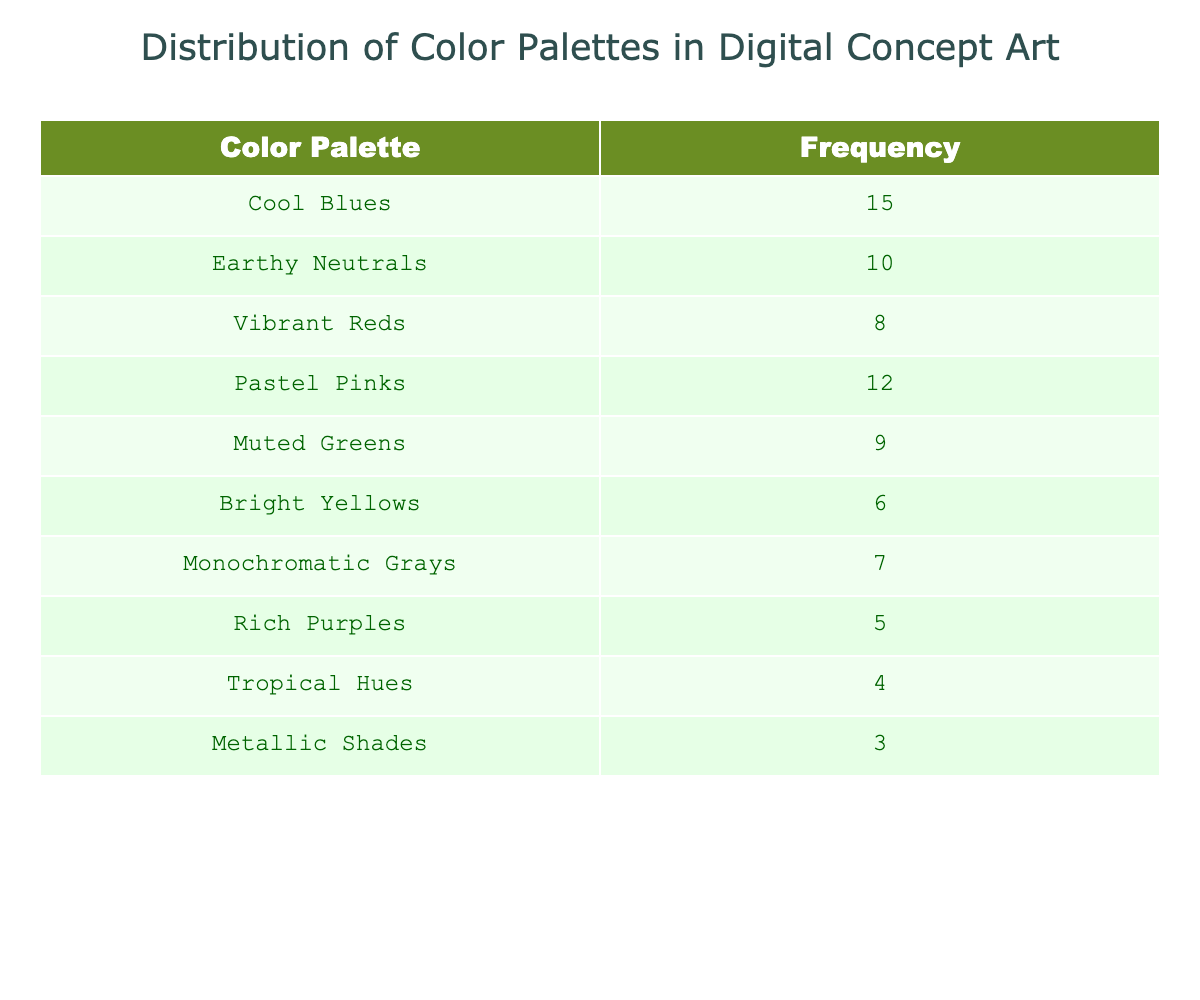What is the frequency of the "Cool Blues" color palette? The table shows that the frequency of the "Cool Blues" color palette is specifically listed under its corresponding row. It states that it is 15.
Answer: 15 Which color palette has the lowest frequency? Looking at the frequencies provided for each color palette, "Metallic Shades" has the lowest frequency, showing a value of 3.
Answer: Metallic Shades What is the total frequency of all color palettes combined? To find the total frequency, we need to sum up all the individual frequencies listed in the table. Adding them up gives: 15 + 10 + 8 + 12 + 9 + 6 + 7 + 5 + 4 + 3 = 79.
Answer: 79 How many color palettes have a frequency greater than 10? We need to review each frequency in the table. The palettes with frequencies greater than 10 are "Cool Blues" (15), "Pastel Pinks" (12), and "Earthy Neutrals" (10). Therefore, two palettes meet this criterion.
Answer: 2 Is the frequency of "Vibrant Reds" equal to the frequency of "Rich Purples"? The table shows that "Vibrant Reds" has a frequency of 8, while "Rich Purples" has a frequency of 5. Since 8 is not equal to 5, the statement is false.
Answer: No What is the average frequency for the color palettes listed in the table? To determine the average frequency, first calculate the total frequency (79), then divide this by the number of palettes (10). Therefore, the average is 79/10 = 7.9.
Answer: 7.9 Which color palette has a frequency that is more than twice that of "Tropical Hues"? First, identify the frequency of "Tropical Hues," which is 4. Twice that frequency is 8. Reviewing the remaining palettes, "Cool Blues" (15), "Earthy Neutrals" (10), and "Pastel Pinks" (12) all have frequencies greater than 8. These three palettes meet the criteria.
Answer: 3 Is the frequency of "Muted Greens" less than or equal to that of "Bright Yellows"? "Muted Greens" has a frequency of 9, while "Bright Yellows" has a frequency of 6. Since 9 is greater than 6, the statement is false.
Answer: No Which color palettes have a frequency of 6 or less? From the table, the frequencies listed are Bright Yellows (6), Metallic Shades (3), and Tropical Hues (4). Therefore, there are three palettes that fit this criterion.
Answer: 3 